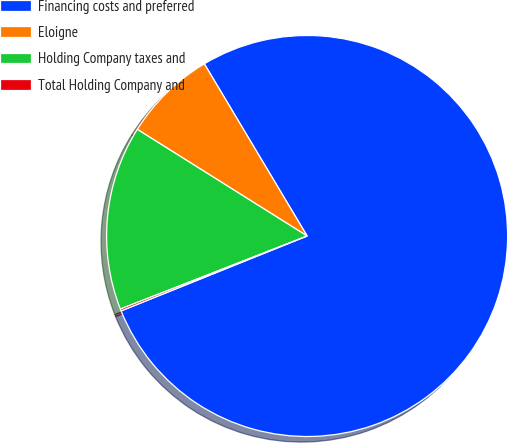Convert chart. <chart><loc_0><loc_0><loc_500><loc_500><pie_chart><fcel>Financing costs and preferred<fcel>Eloigne<fcel>Holding Company taxes and<fcel>Total Holding Company and<nl><fcel>77.48%<fcel>7.51%<fcel>14.86%<fcel>0.16%<nl></chart> 